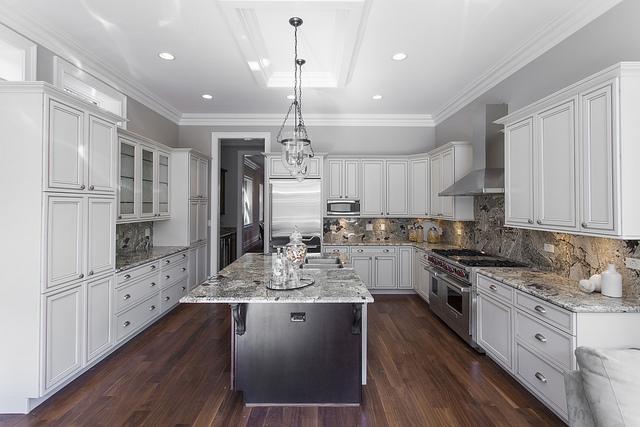What are the counters made of?
Be succinct. Marble. What type of light is hanging down?
Quick response, please. Chandelier. Are the appliances made with stainless steel?
Quick response, please. Yes. 